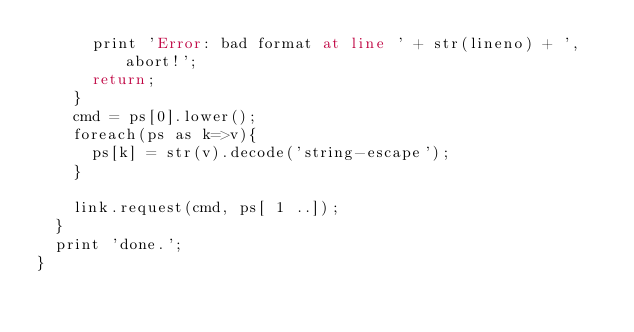Convert code to text. <code><loc_0><loc_0><loc_500><loc_500><_COBOL_>			print 'Error: bad format at line ' + str(lineno) + ', abort!';
			return;
		}
		cmd = ps[0].lower();
		foreach(ps as k=>v){
			ps[k] = str(v).decode('string-escape');
		}
		
		link.request(cmd, ps[ 1 ..]);
	}
	print 'done.';
}
</code> 